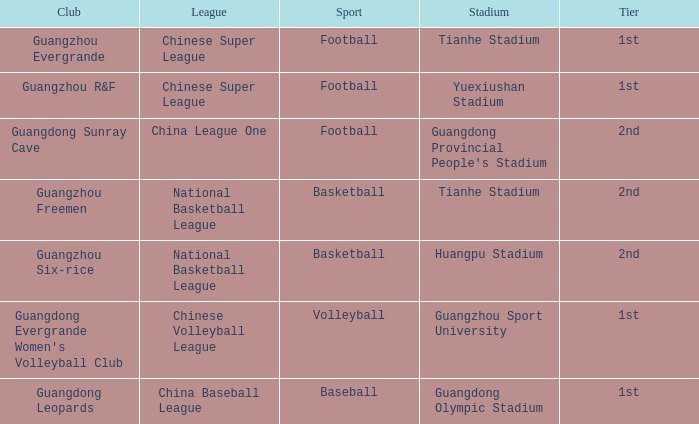Which stadium is for football with the China League One? Guangdong Provincial People's Stadium. 